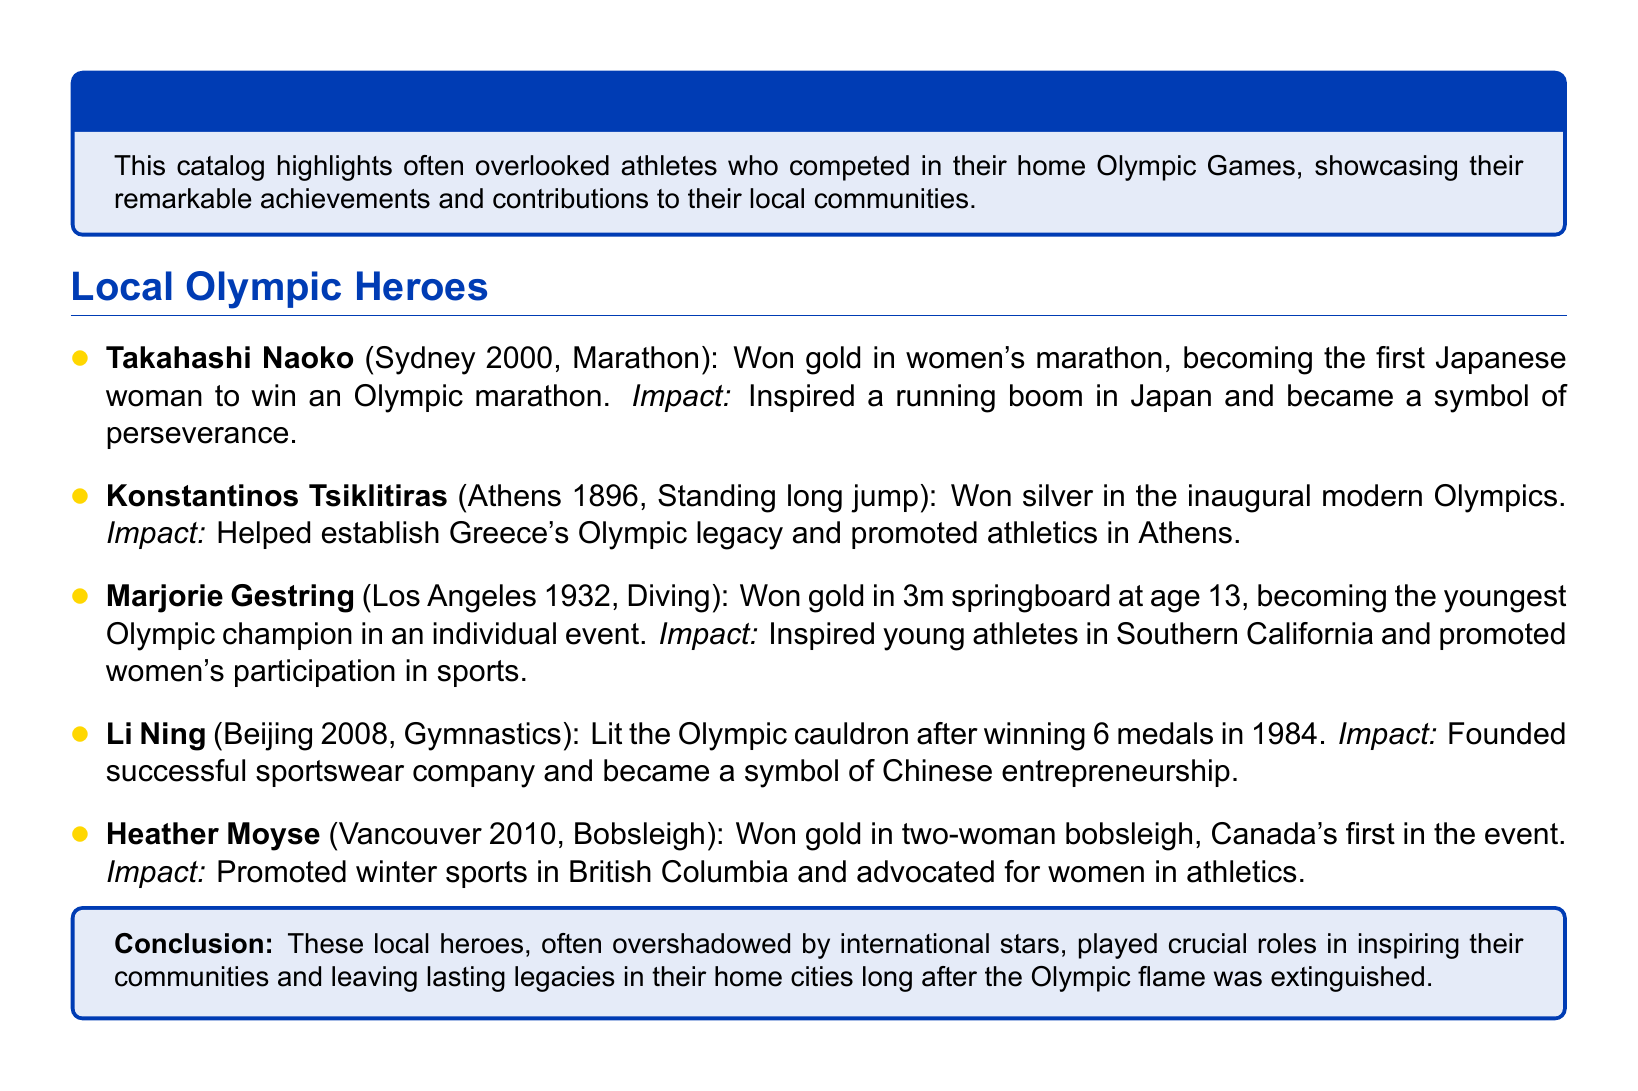What was Takahashi Naoko's event? Takahashi Naoko competed in the women's marathon during the Sydney 2000 Olympics.
Answer: Marathon How old was Marjorie Gestring when she won her gold medal? Marjorie Gestring became the youngest Olympic champion at age 13 in the Los Angeles 1932 Olympics.
Answer: 13 In which year did Heather Moyse win her gold medal? Heather Moyse won gold in the two-woman bobsleigh event at the Vancouver 2010 Olympics.
Answer: 2010 What impact did Konstantinos Tsiklitiras have on athletics? Konstantinos Tsiklitiras helped establish Greece's Olympic legacy and promoted athletics in Athens.
Answer: Established Greece's Olympic legacy How many medals did Li Ning win in the 1984 Olympics? Li Ning won 6 medals in gymnastics at the 1984 Olympics and later lit the Olympic cauldron in Beijing 2008.
Answer: 6 What is the common theme among the athletes featured in this catalog? The athletes highlighted are local heroes who competed in their home Olympic Games and had significant local impact.
Answer: Local heroes What type of document is this? The document is a catalog showcasing local Olympic athletes who are often overlooked.
Answer: Catalog 